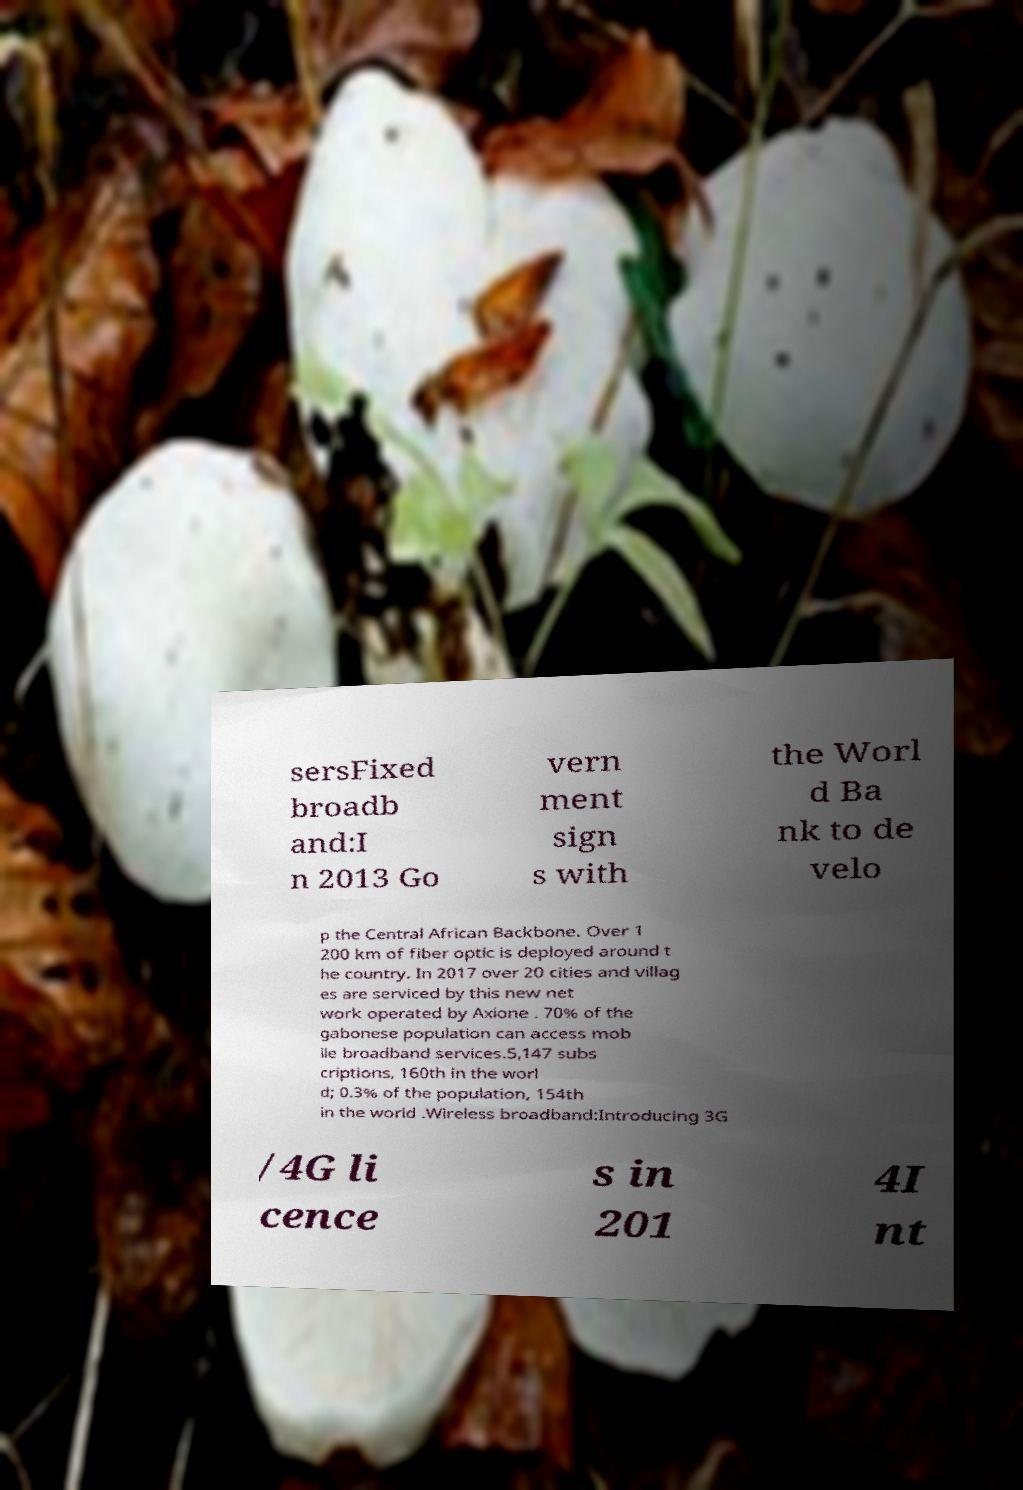Can you read and provide the text displayed in the image?This photo seems to have some interesting text. Can you extract and type it out for me? sersFixed broadb and:I n 2013 Go vern ment sign s with the Worl d Ba nk to de velo p the Central African Backbone. Over 1 200 km of fiber optic is deployed around t he country. In 2017 over 20 cities and villag es are serviced by this new net work operated by Axione . 70% of the gabonese population can access mob ile broadband services.5,147 subs criptions, 160th in the worl d; 0.3% of the population, 154th in the world .Wireless broadband:Introducing 3G /4G li cence s in 201 4I nt 